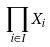<formula> <loc_0><loc_0><loc_500><loc_500>\prod _ { i \in I } X _ { i }</formula> 